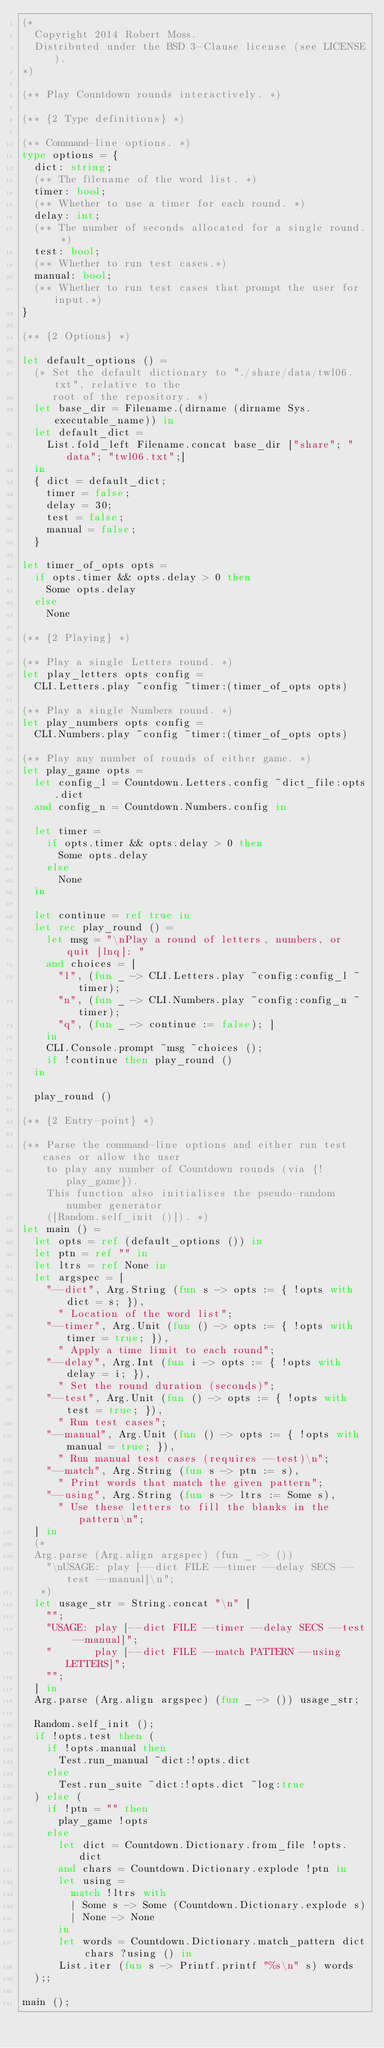Convert code to text. <code><loc_0><loc_0><loc_500><loc_500><_OCaml_>(*
  Copyright 2014 Robert Moss.
  Distributed under the BSD 3-Clause license (see LICENSE).
*)

(** Play Countdown rounds interactively. *)

(** {2 Type definitions} *)

(** Command-line options. *)
type options = {
  dict: string;
  (** The filename of the word list. *)
  timer: bool;
  (** Whether to use a timer for each round. *)
  delay: int;
  (** The number of seconds allocated for a single round. *)
  test: bool;
  (** Whether to run test cases.*)
  manual: bool;
  (** Whether to run test cases that prompt the user for input.*)
}

(** {2 Options} *)

let default_options () =
  (* Set the default dictionary to "./share/data/twl06.txt", relative to the
     root of the repository. *)
  let base_dir = Filename.(dirname (dirname Sys.executable_name)) in
  let default_dict =
    List.fold_left Filename.concat base_dir ["share"; "data"; "twl06.txt";]
  in
  { dict = default_dict;
    timer = false;
    delay = 30;
    test = false;
    manual = false;
  }

let timer_of_opts opts =
  if opts.timer && opts.delay > 0 then
    Some opts.delay
  else
    None

(** {2 Playing} *)

(** Play a single Letters round. *)
let play_letters opts config =
  CLI.Letters.play ~config ~timer:(timer_of_opts opts)

(** Play a single Numbers round. *)
let play_numbers opts config =
  CLI.Numbers.play ~config ~timer:(timer_of_opts opts)

(** Play any number of rounds of either game. *)
let play_game opts =
  let config_l = Countdown.Letters.config ~dict_file:opts.dict
  and config_n = Countdown.Numbers.config in

  let timer =
    if opts.timer && opts.delay > 0 then
      Some opts.delay
    else
      None
  in

  let continue = ref true in
  let rec play_round () =
    let msg = "\nPlay a round of letters, numbers, or quit [lnq]: "
    and choices = [
      "l", (fun _ -> CLI.Letters.play ~config:config_l ~timer);
      "n", (fun _ -> CLI.Numbers.play ~config:config_n ~timer);
      "q", (fun _ -> continue := false); ]
    in
    CLI.Console.prompt ~msg ~choices ();
    if !continue then play_round ()
  in

  play_round ()

(** {2 Entry-point} *)

(** Parse the command-line options and either run test cases or allow the user
    to play any number of Countdown rounds (via {!play_game}).
    This function also initialises the pseudo-random number generator
    ([Random.self_init ()]). *)
let main () =
  let opts = ref (default_options ()) in
  let ptn = ref "" in
  let ltrs = ref None in
  let argspec = [
    "--dict", Arg.String (fun s -> opts := { !opts with dict = s; }),
      " Location of the word list";
    "--timer", Arg.Unit (fun () -> opts := { !opts with timer = true; }),
      " Apply a time limit to each round";
    "--delay", Arg.Int (fun i -> opts := { !opts with delay = i; }),
      " Set the round duration (seconds)";
    "--test", Arg.Unit (fun () -> opts := { !opts with test = true; }),
      " Run test cases";
    "--manual", Arg.Unit (fun () -> opts := { !opts with manual = true; }),
      " Run manual test cases (requires --test)\n";
    "--match", Arg.String (fun s -> ptn := s),
      " Print words that match the given pattern";
    "--using", Arg.String (fun s -> ltrs := Some s),
      " Use these letters to fill the blanks in the pattern\n";
  ] in
  (*
  Arg.parse (Arg.align argspec) (fun _ -> ())
    "\nUSAGE: play [--dict FILE --timer --delay SECS --test --manual]\n";
   *)
  let usage_str = String.concat "\n" [
    "";
    "USAGE: play [--dict FILE --timer --delay SECS --test --manual]";
    "       play [--dict FILE --match PATTERN --using LETTERS]";
    "";
  ] in
  Arg.parse (Arg.align argspec) (fun _ -> ()) usage_str;

  Random.self_init ();
  if !opts.test then (
    if !opts.manual then
      Test.run_manual ~dict:!opts.dict
    else
      Test.run_suite ~dict:!opts.dict ~log:true
  ) else (
    if !ptn = "" then
      play_game !opts
    else
      let dict = Countdown.Dictionary.from_file !opts.dict
      and chars = Countdown.Dictionary.explode !ptn in
      let using =
        match !ltrs with
        | Some s -> Some (Countdown.Dictionary.explode s)
        | None -> None
      in
      let words = Countdown.Dictionary.match_pattern dict chars ?using () in
      List.iter (fun s -> Printf.printf "%s\n" s) words
  );;

main ();
</code> 